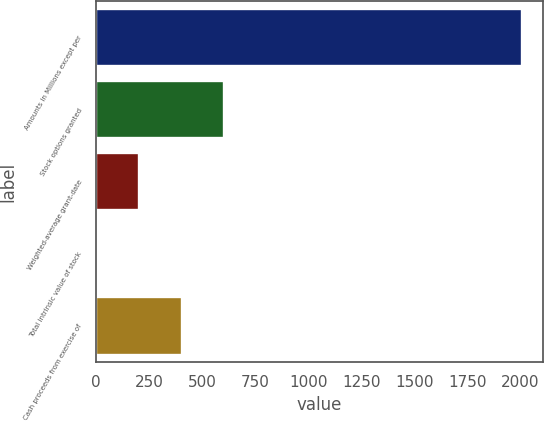<chart> <loc_0><loc_0><loc_500><loc_500><bar_chart><fcel>Amounts in Millions except per<fcel>Stock options granted<fcel>Weighted-average grant-date<fcel>Total intrinsic value of stock<fcel>Cash proceeds from exercise of<nl><fcel>2008<fcel>603.8<fcel>202.6<fcel>2<fcel>403.2<nl></chart> 